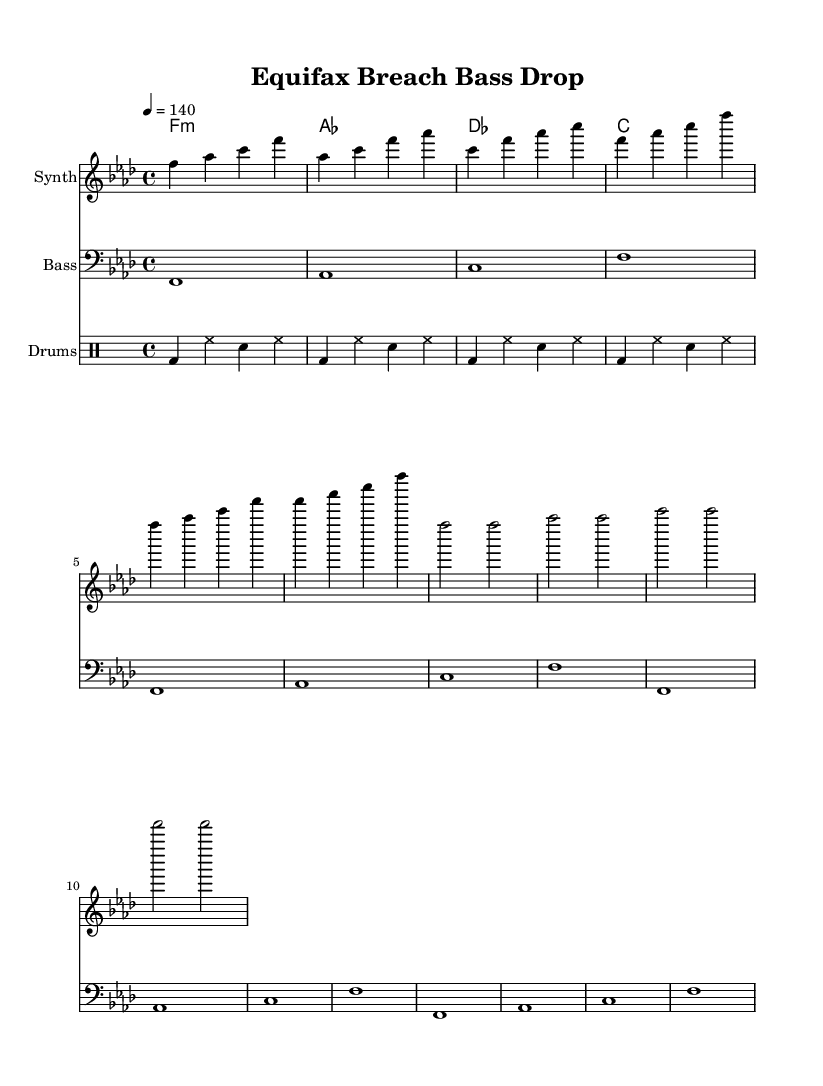What is the key signature of this music? The key signature is indicated at the beginning of the music, where one flat is shown on the staff. This corresponds to F minor.
Answer: F minor What is the time signature of this music? The time signature appears at the start of the score and is represented by "4/4", which tells us there are four beats in each measure.
Answer: 4/4 What is the tempo marking of the music? The tempo is specified at the top of the score as "4 = 140", meaning there are 140 beats per minute when playing.
Answer: 140 How many measures are in the drop section? By counting the measures noted in the bass and synth parts specifically within the drop section, we determine that there are four measures present.
Answer: 4 Which instrument is playing the chord progression? The chord names are listed above the staff, indicating that the chord progression is played by the synth instrument below.
Answer: Synth What sequence of events occurs right before the drop? The music features a repeated build-up phrase that leads directly into the drop section, as indicated in the synth part.
Answer: Build-up What type of rhythm pattern do the drums follow? The drum part features a basic rhythm described in a drummode format, showing a pattern that repeats every four beats.
Answer: Basic 